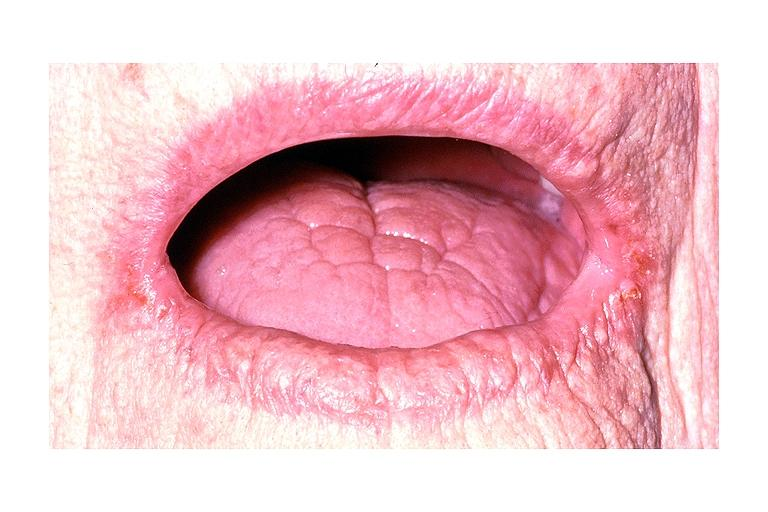s nodular parenchyma and dense present?
Answer the question using a single word or phrase. No 